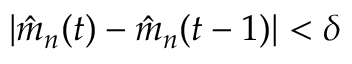<formula> <loc_0><loc_0><loc_500><loc_500>| \hat { m } _ { n } ( t ) - \hat { m } _ { n } ( t - 1 ) | < \delta</formula> 